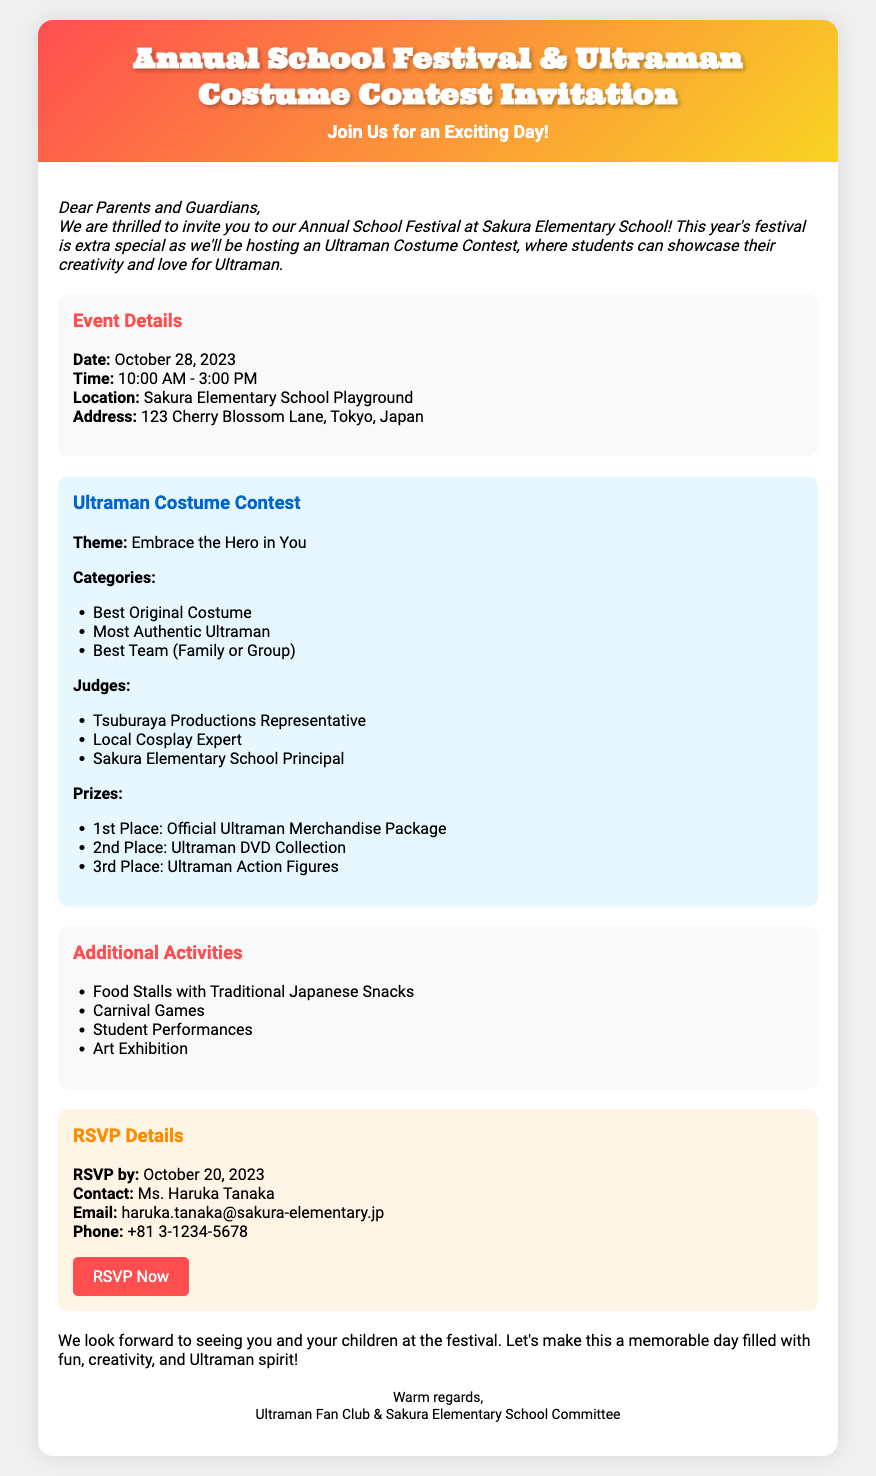what is the date of the festival? The date of the festival is mentioned clearly in the document.
Answer: October 28, 2023 what is the event's location? The location is specified in the details section of the document.
Answer: Sakura Elementary School Playground who is the contact person for RSVP? The contact person is stated under the RSVP details section.
Answer: Ms. Haruka Tanaka what is the theme of the costume contest? The theme for the costume contest is provided in the contest section.
Answer: Embrace the Hero in You how many prize categories are there for the contest? The number of categories is listed in the contest section.
Answer: Three what time does the festival start? The starting time of the festival can be found in the event details.
Answer: 10:00 AM what is the deadline for RSVP? The RSVP deadline is clearly listed in the document.
Answer: October 20, 2023 what is the prize for the 1st place winner? The prize for the 1st place winner is outlined in the contest details.
Answer: Official Ultraman Merchandise Package what type of stalls will be available at the event? The types of stalls available are listed in the additional activities section.
Answer: Food Stalls with Traditional Japanese Snacks 